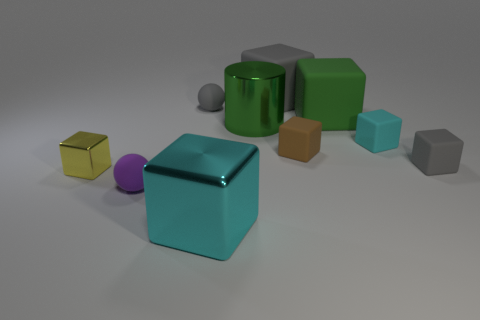Subtract 5 blocks. How many blocks are left? 2 Subtract all small gray matte blocks. How many blocks are left? 6 Subtract all green cubes. How many cubes are left? 6 Subtract all red blocks. Subtract all gray cylinders. How many blocks are left? 7 Subtract all cubes. How many objects are left? 3 Add 2 tiny cyan blocks. How many tiny cyan blocks exist? 3 Subtract 0 brown cylinders. How many objects are left? 10 Subtract all small yellow metal things. Subtract all small objects. How many objects are left? 3 Add 4 gray cubes. How many gray cubes are left? 6 